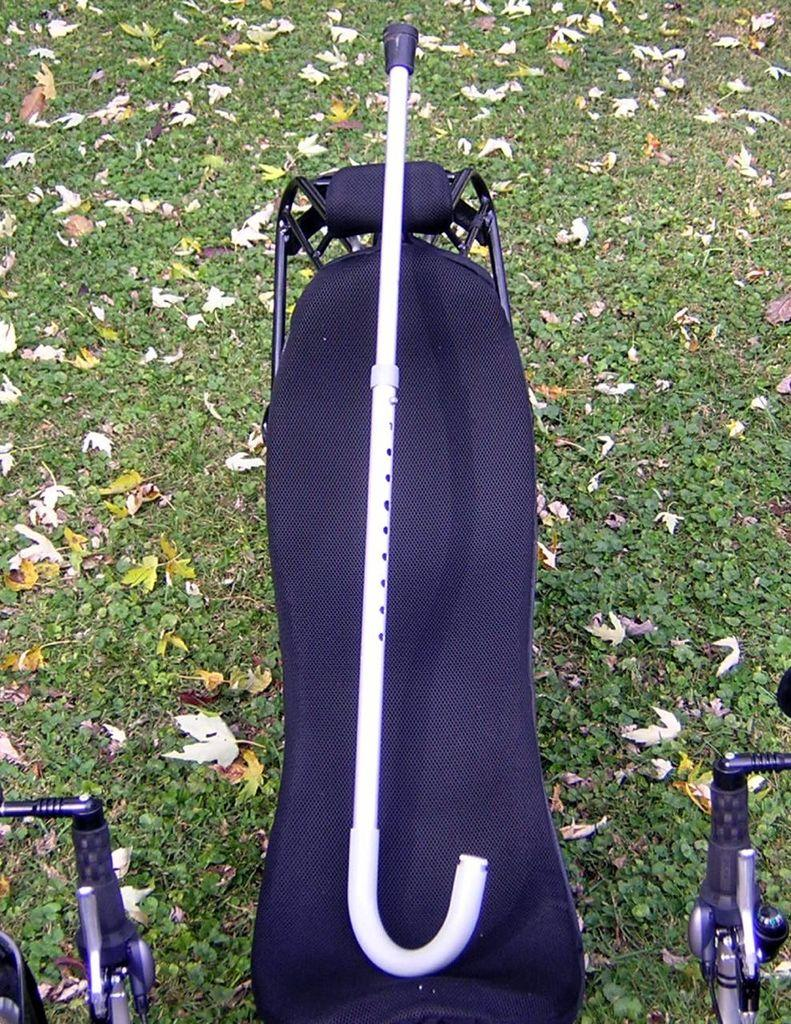What is the main object in the center of the image? There is a flat bench in the center of the image. What is placed on the bench? A walking stick is present on the bench. What type of ground is visible below the bench? There is grass with dried leaves below the bench. Reasoning: Let's think step by step by step in order to produce the conversation. We start by identifying the main object in the image, which is the flat bench. Then, we describe the additional object on the bench, which is the walking stick. Finally, we mention the type of ground visible below the bench, which is grass with dried leaves. Each question is designed to elicit a specific detail about the image that is known from the provided facts. Absurd Question/Answer: What type of government is depicted in the image? There is no depiction of a government in the image; it features a flat bench, a walking stick, and grass with dried leaves. What style of prose is used in the image? The image is not a piece of prose; it is a visual representation of a flat bench, a walking stick, and grass with dried leaves. 